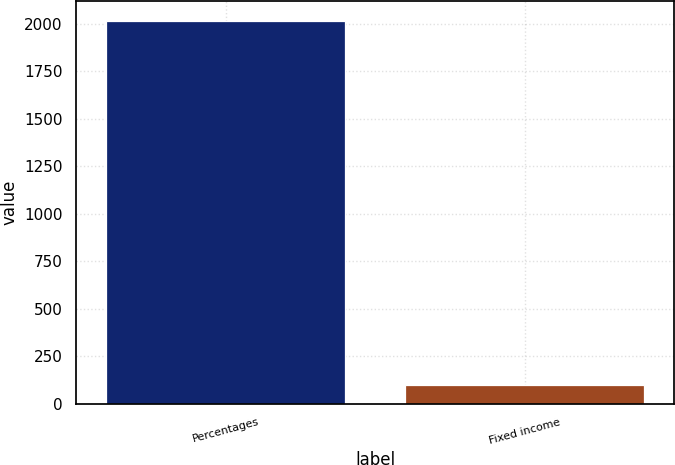Convert chart to OTSL. <chart><loc_0><loc_0><loc_500><loc_500><bar_chart><fcel>Percentages<fcel>Fixed income<nl><fcel>2016<fcel>100<nl></chart> 